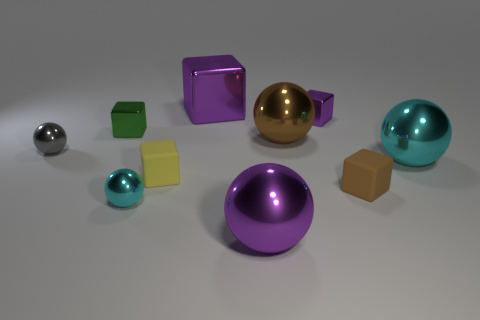Subtract 1 balls. How many balls are left? 4 Subtract all purple blocks. How many blocks are left? 3 Subtract all yellow matte cubes. How many cubes are left? 4 Subtract all cyan blocks. Subtract all blue cylinders. How many blocks are left? 5 Add 2 large cubes. How many large cubes exist? 3 Subtract 1 brown cubes. How many objects are left? 9 Subtract all small gray cylinders. Subtract all small green shiny objects. How many objects are left? 9 Add 3 tiny yellow matte blocks. How many tiny yellow matte blocks are left? 4 